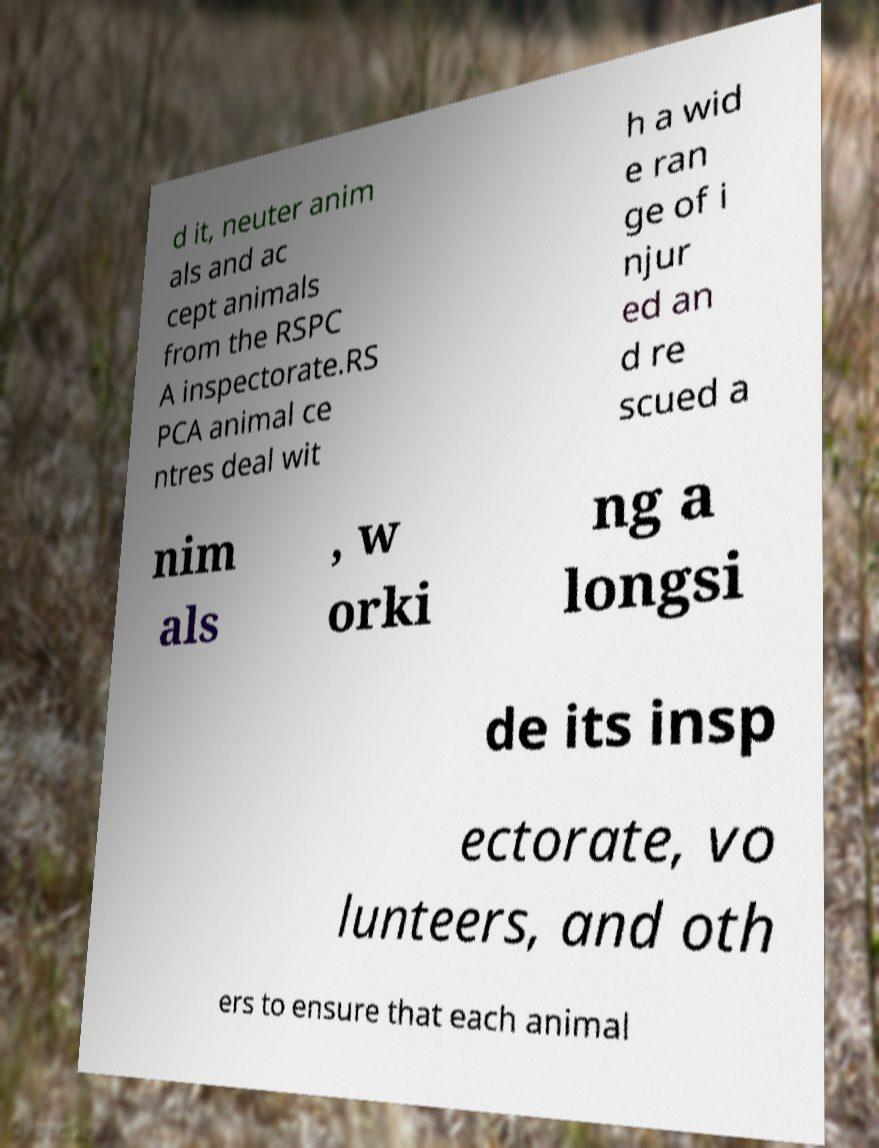Please identify and transcribe the text found in this image. d it, neuter anim als and ac cept animals from the RSPC A inspectorate.RS PCA animal ce ntres deal wit h a wid e ran ge of i njur ed an d re scued a nim als , w orki ng a longsi de its insp ectorate, vo lunteers, and oth ers to ensure that each animal 